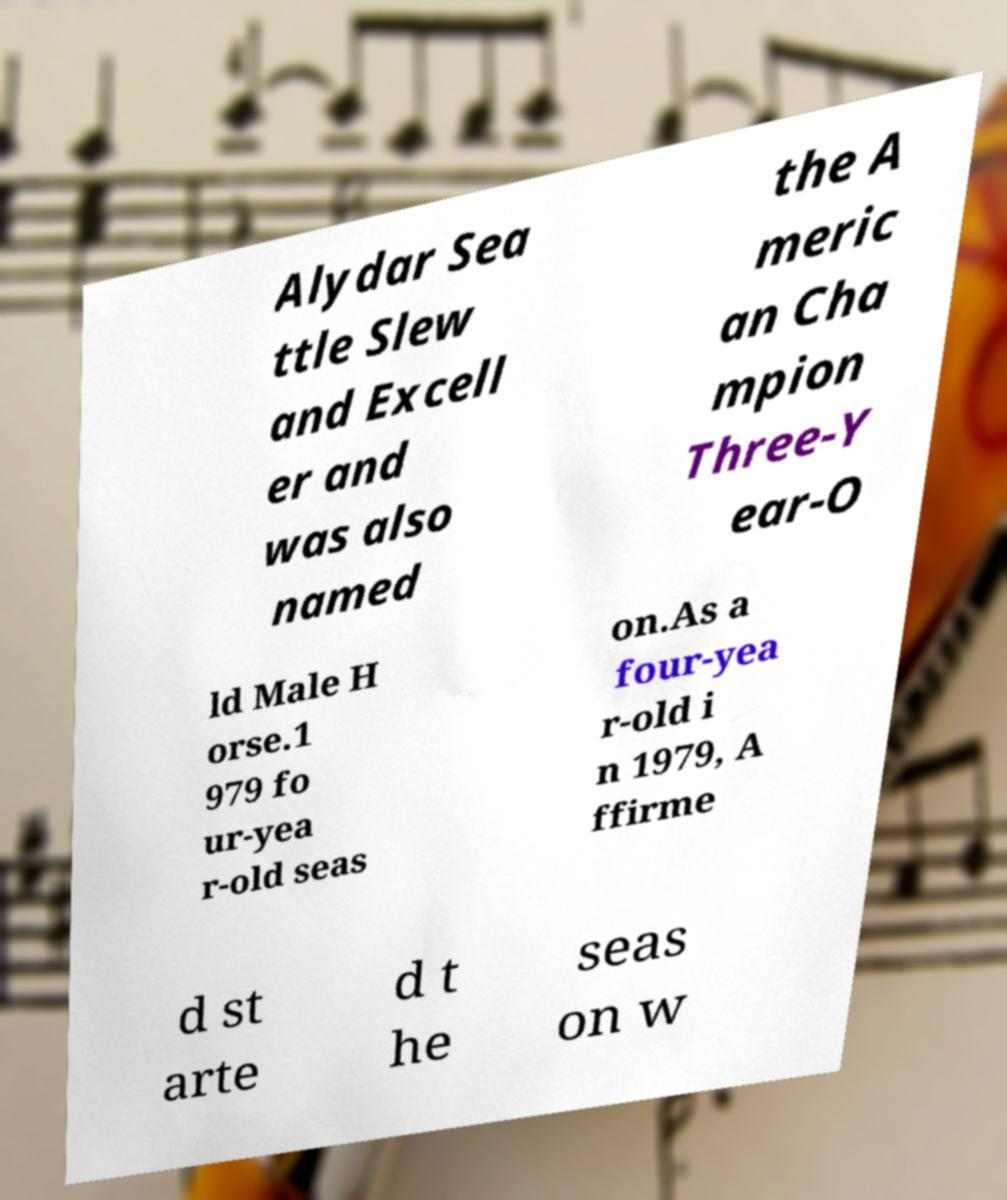I need the written content from this picture converted into text. Can you do that? Alydar Sea ttle Slew and Excell er and was also named the A meric an Cha mpion Three-Y ear-O ld Male H orse.1 979 fo ur-yea r-old seas on.As a four-yea r-old i n 1979, A ffirme d st arte d t he seas on w 